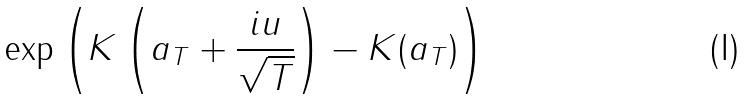<formula> <loc_0><loc_0><loc_500><loc_500>\exp \left ( K \left ( a _ { T } + \frac { i u } { \sqrt { T } } \right ) - K ( a _ { T } ) \right )</formula> 